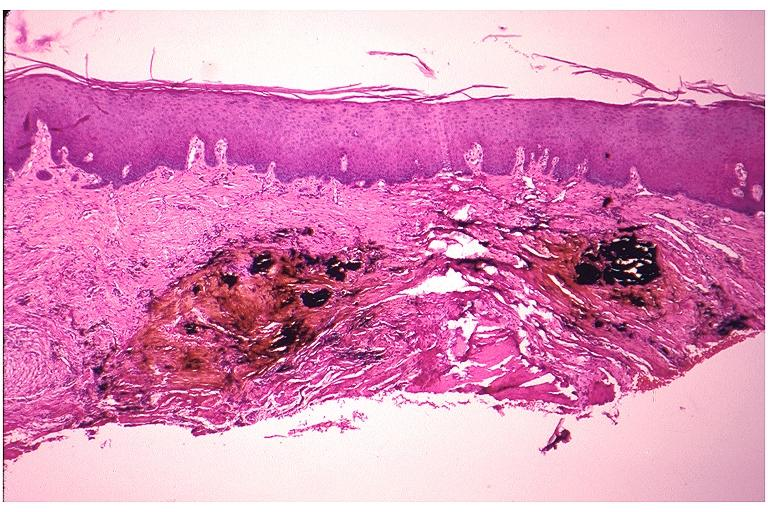does malignant lymphoma show amalgam tattoo?
Answer the question using a single word or phrase. No 